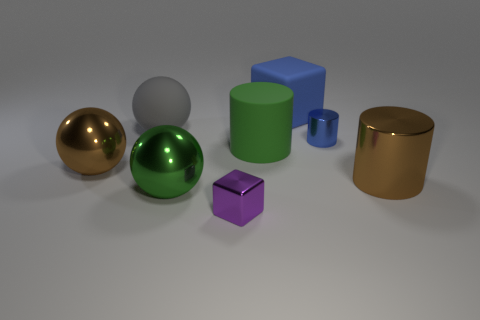Subtract all big shiny spheres. How many spheres are left? 1 Add 2 big things. How many objects exist? 10 Subtract 3 spheres. How many spheres are left? 0 Subtract all green balls. How many balls are left? 2 Subtract all cubes. How many objects are left? 6 Add 7 matte cylinders. How many matte cylinders exist? 8 Subtract 0 purple spheres. How many objects are left? 8 Subtract all purple cylinders. Subtract all red blocks. How many cylinders are left? 3 Subtract all big cylinders. Subtract all small purple metallic things. How many objects are left? 5 Add 4 large gray balls. How many large gray balls are left? 5 